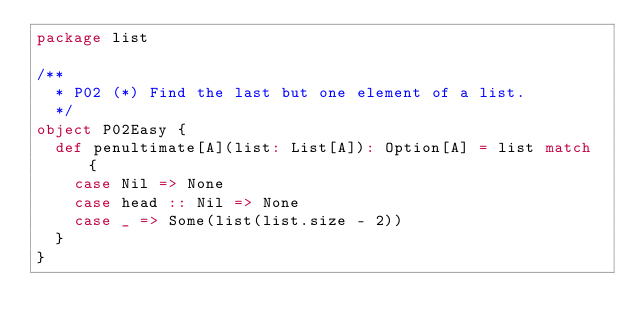<code> <loc_0><loc_0><loc_500><loc_500><_Scala_>package list

/**
  * P02 (*) Find the last but one element of a list.
  */
object P02Easy {
  def penultimate[A](list: List[A]): Option[A] = list match {
    case Nil => None
    case head :: Nil => None
    case _ => Some(list(list.size - 2))
  }
}
</code> 